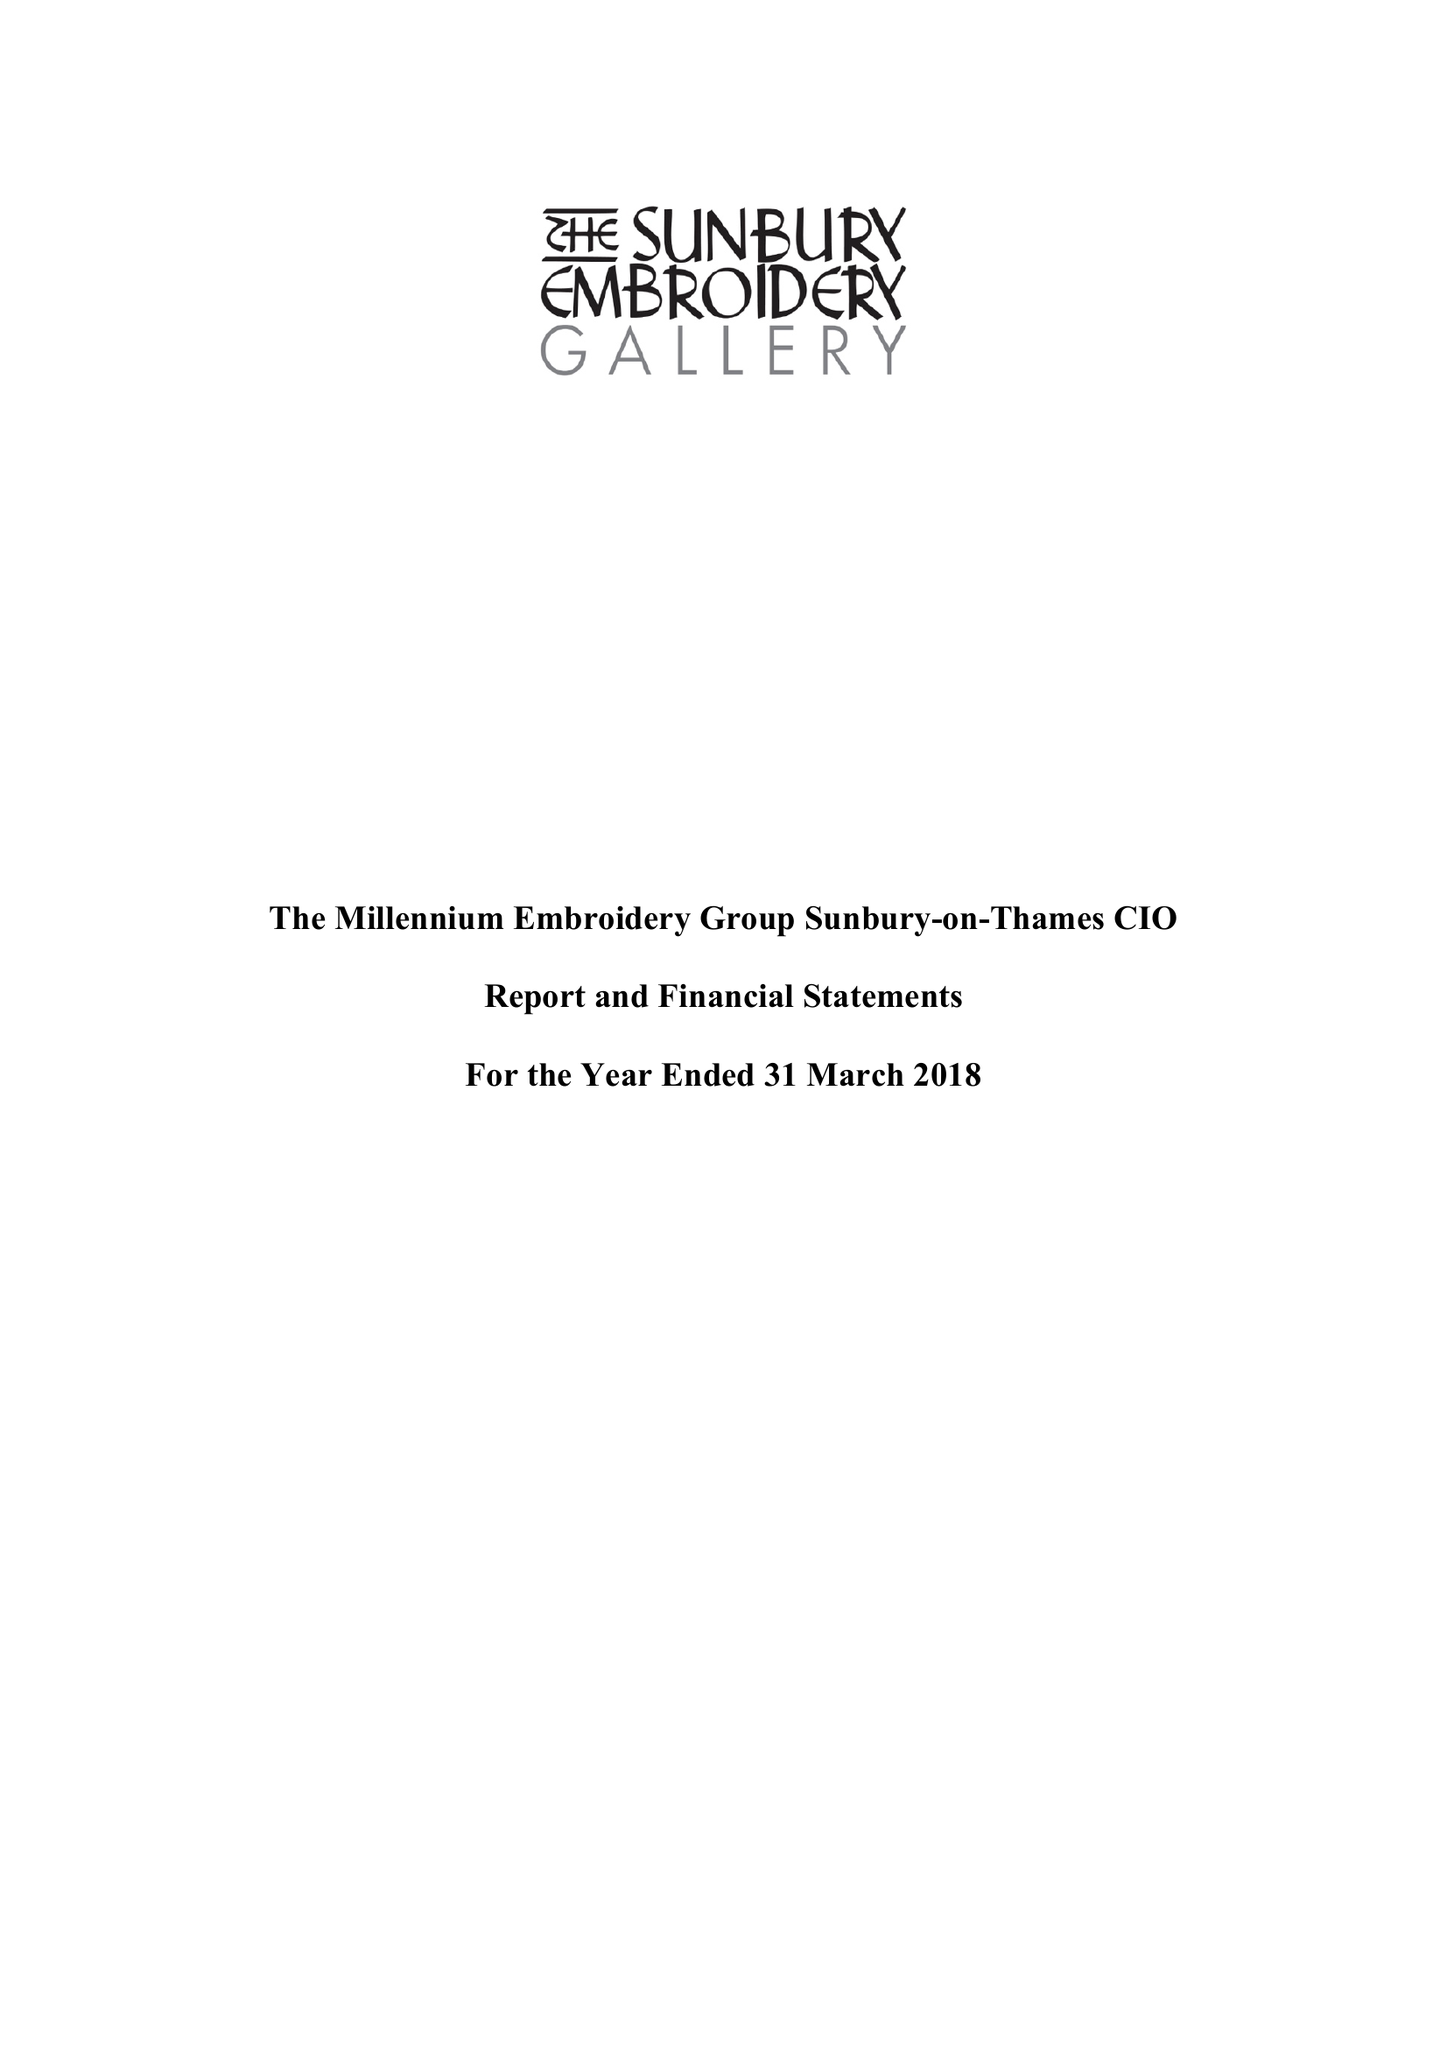What is the value for the charity_name?
Answer the question using a single word or phrase. The Millennium Embroidery Group Sunbury-On-Thames 